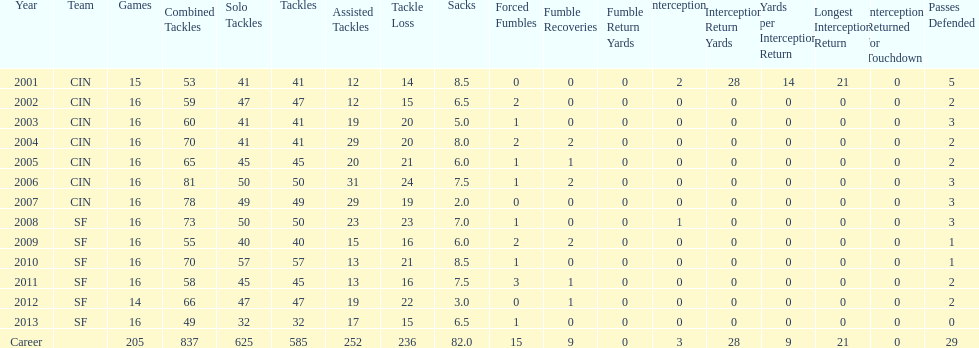How many years did he play in less than 16 games? 2. 